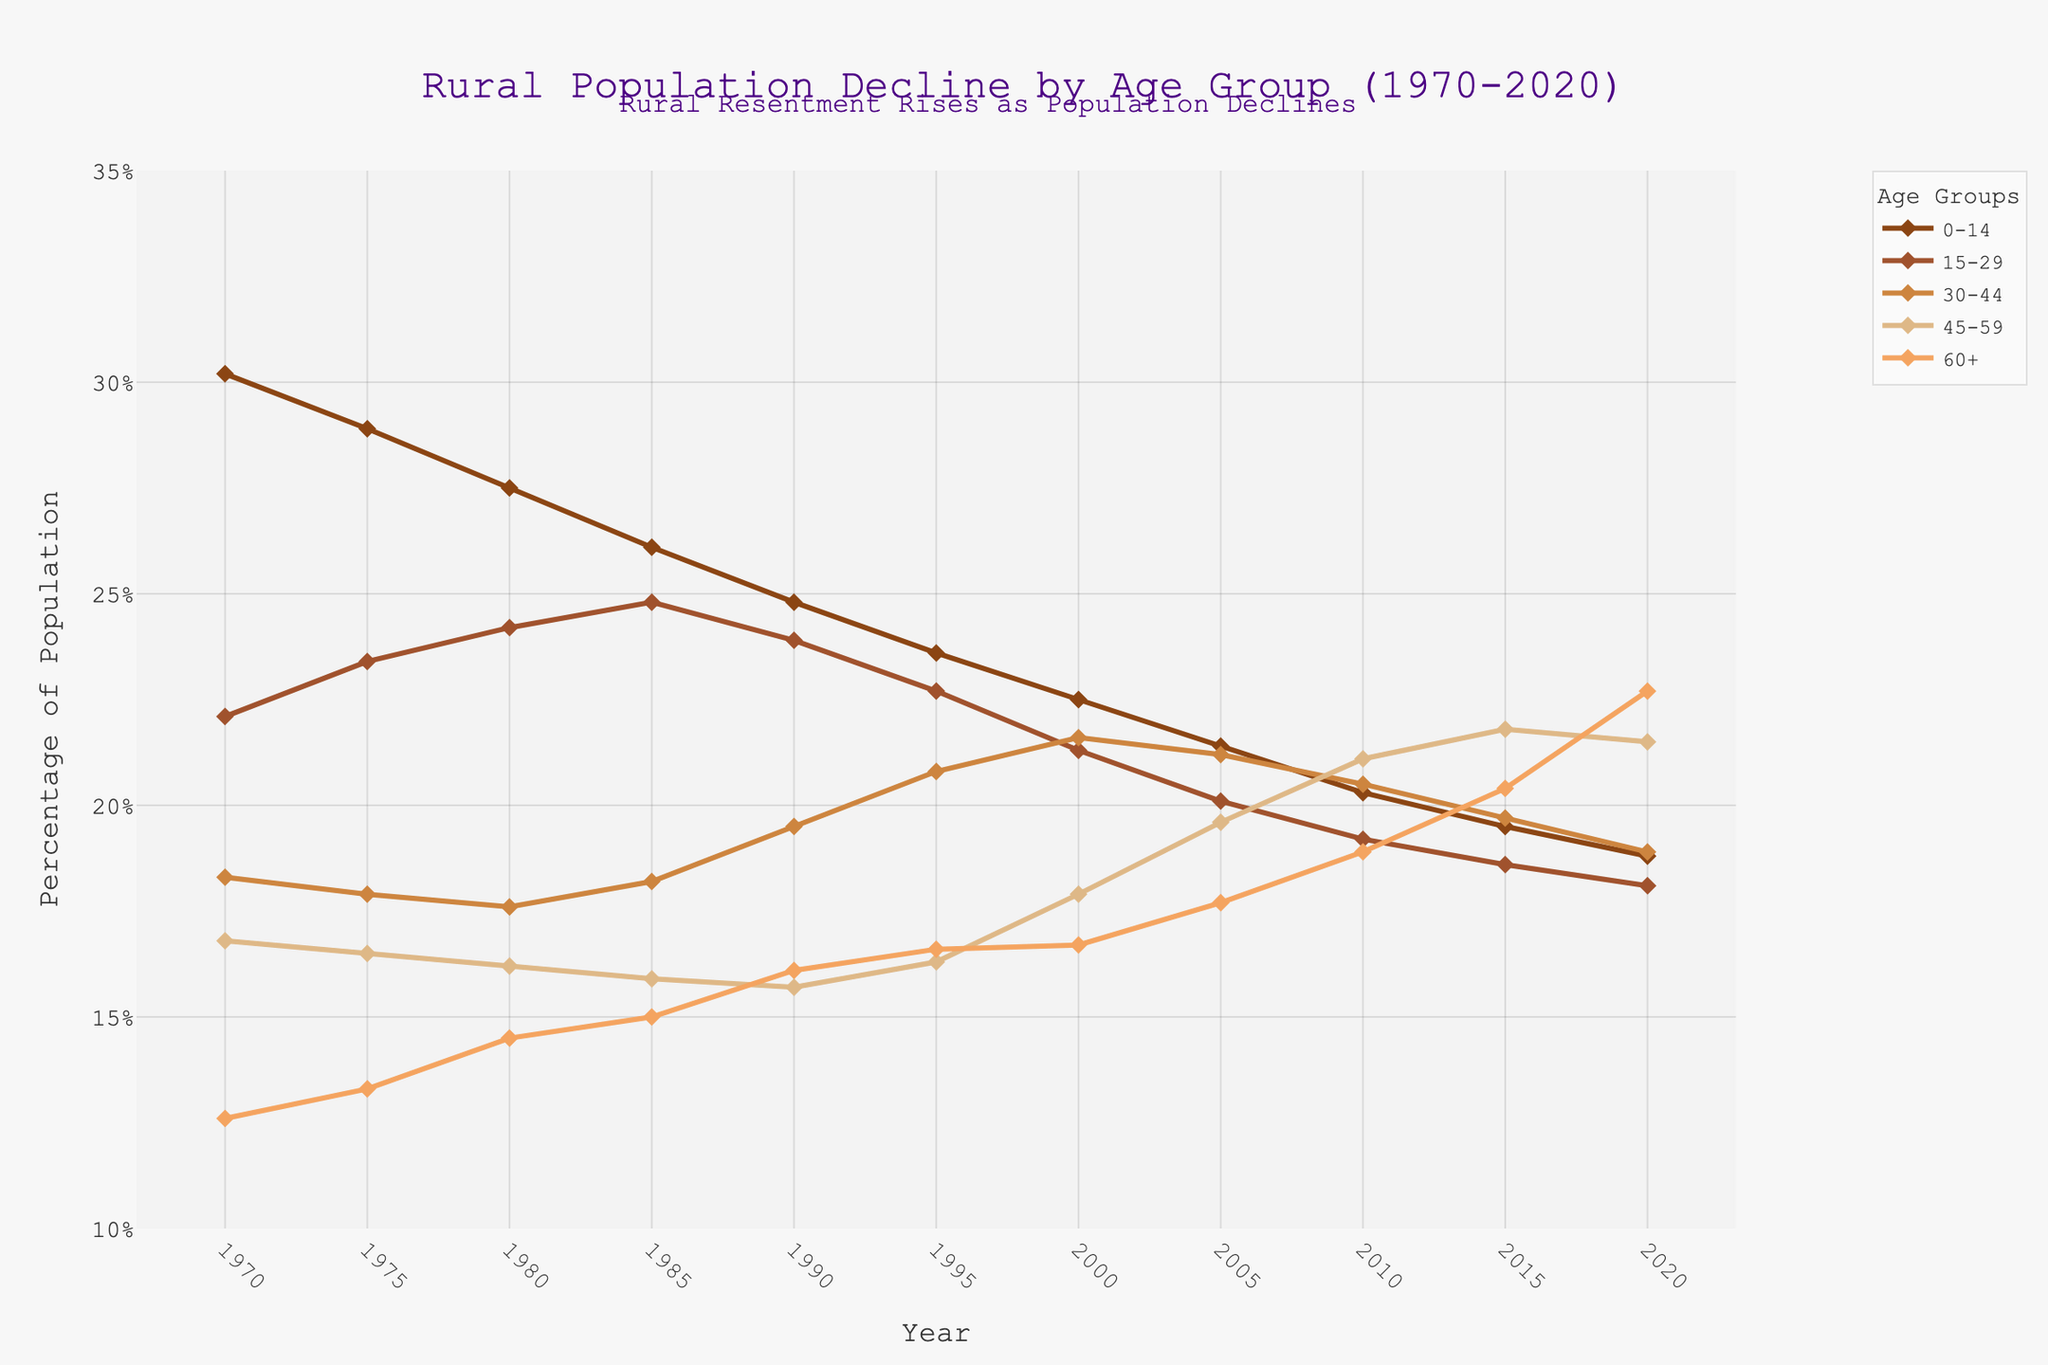Which age group had the highest percentage in 1970? To determine this, refer to the starting values for each age group in 1970. The highest value is 30.2% for the age group 0-14.
Answer: 0-14 Which age group saw the biggest decline from 1970 to 2020? Calculate the difference between the 1970 and 2020 values for each age group. The differences are: 0-14 (-11.4), 15-29 (-4), 30-44 (0.6), 45-59 (4.7), 60+ (10.1). The biggest decline is -11.4 for the age group 0-14.
Answer: 0-14 How did the percentage of the 60+ age group change between 1980 and 2020? Find the percentage of the 60+ age group in 1980 (14.5%) and 2020 (22.7%). The change is 22.7 - 14.5 = 8.2%.
Answer: Increased by 8.2% In which decade was the percentage increase for the 45-59 age group the highest? Calculate the increase decade by decade: 1970-1980 (0.6), 1980-1990 (-0.5), 1990-2000 (2.2), 2000-2010 (3.2), 2010-2020 (0.4). The highest increase is from 2000 to 2010 (3.2).
Answer: 2000-2010 Which age group remained relatively stable in percentage from 1970 to 2020? Observe the trends over the 50 years. The age group 30-44 has a slight increase from 18.3% to 18.9%, showing relative stability.
Answer: 30-44 Compare the population percentage trends between the age groups 0-14 and 60+ from 1970 to 2020. The 0-14 group steadily declines from 30.2% to 18.8%, while the 60+ group rises from 12.6% to 22.7%.
Answer: 0-14 declines, 60+ rises Which year had the smallest percentage difference between the 0-14 and 60+ age groups? Calculate the percentage difference for each year. The smallest difference is in 2020, with 18.8% for 0-14 and 22.7% for 60+, resulting in a difference of 3.9%.
Answer: 2020 What's the average percentage of the 15-29 age group over the 50-year period? Sum the percentages for 15-29 from 1970 to 2020 and divide by the number of years. (22.1+23.4+24.2+24.8+23.9+22.7+21.3+20.1+19.2+18.6+18.1)/11 = 21.72%.
Answer: 21.72% By how much did the percentage of the 30-44 age group change from 1985 to 2005? Find the percentage difference for the 30-44 age group between 1985 (18.2%) and 2005 (21.2%). The change is 21.2 - 18.2 = 3%.
Answer: Increased by 3% Which age group shows a continuous increase in their percentage throughout the 50 years? Visually inspect the trend lines, the 60+ age group shows a continuous increase from 12.6% in 1970 to 22.7% in 2020.
Answer: 60+ 